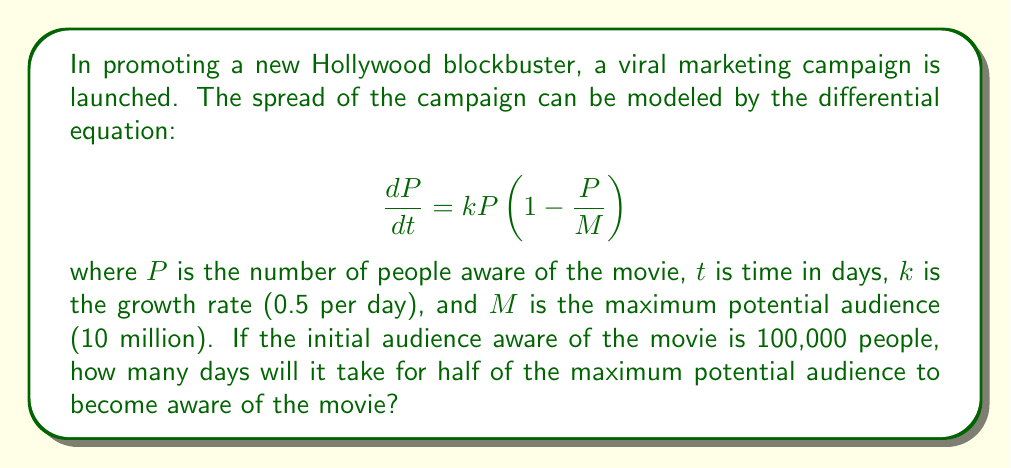Provide a solution to this math problem. To solve this problem, we'll follow these steps:

1) The given differential equation is a logistic growth model. The solution to this equation is:

   $$P(t) = \frac{M}{1 + (\frac{M}{P_0} - 1)e^{-kt}}$$

   where $P_0$ is the initial population.

2) We're given:
   $M = 10,000,000$
   $k = 0.5$
   $P_0 = 100,000$

3) We want to find $t$ when $P(t) = M/2 = 5,000,000$

4) Let's substitute these values into the equation:

   $$5,000,000 = \frac{10,000,000}{1 + (\frac{10,000,000}{100,000} - 1)e^{-0.5t}}$$

5) Simplify:

   $$\frac{1}{2} = \frac{1}{1 + 99e^{-0.5t}}$$

6) Solve for $t$:
   
   $$1 + 99e^{-0.5t} = 2$$
   $$99e^{-0.5t} = 1$$
   $$e^{-0.5t} = \frac{1}{99}$$
   $$-0.5t = \ln(\frac{1}{99})$$
   $$t = -2\ln(\frac{1}{99}) \approx 9.19$$

7) Therefore, it will take approximately 9.19 days for half of the maximum potential audience to become aware of the movie.
Answer: 9.19 days 